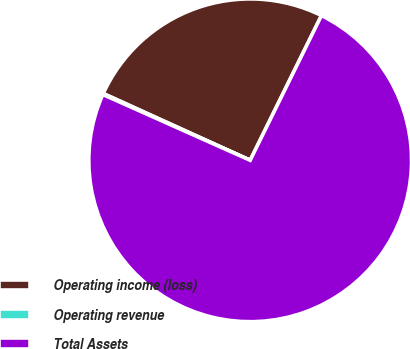<chart> <loc_0><loc_0><loc_500><loc_500><pie_chart><fcel>Operating income (loss)<fcel>Operating revenue<fcel>Total Assets<nl><fcel>25.49%<fcel>0.11%<fcel>74.4%<nl></chart> 